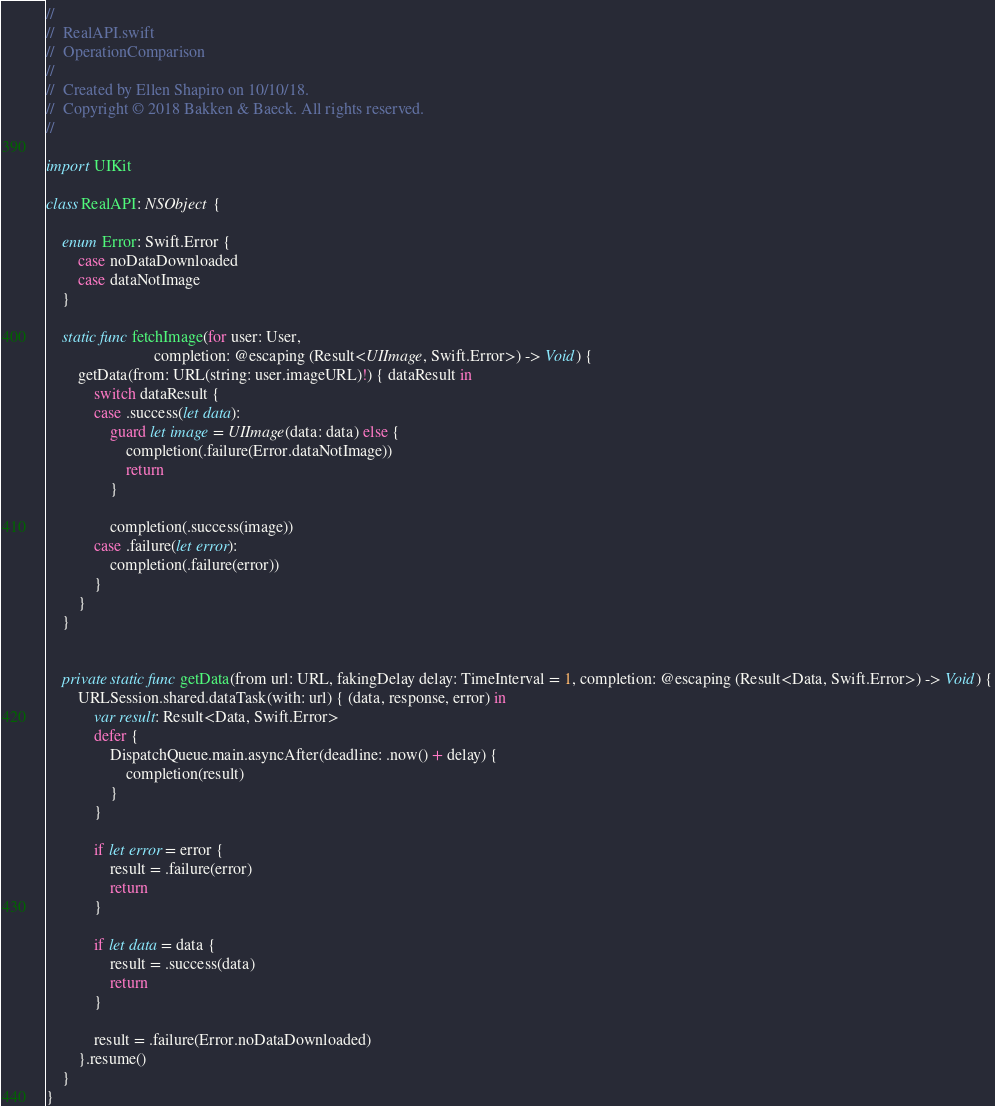Convert code to text. <code><loc_0><loc_0><loc_500><loc_500><_Swift_>//
//  RealAPI.swift
//  OperationComparison
//
//  Created by Ellen Shapiro on 10/10/18.
//  Copyright © 2018 Bakken & Baeck. All rights reserved.
//

import UIKit

class RealAPI: NSObject {
    
    enum Error: Swift.Error {
        case noDataDownloaded
        case dataNotImage
    }
    
    static func fetchImage(for user: User,
                           completion: @escaping (Result<UIImage, Swift.Error>) -> Void) {
        getData(from: URL(string: user.imageURL)!) { dataResult in
            switch dataResult {
            case .success(let data):
                guard let image = UIImage(data: data) else {
                    completion(.failure(Error.dataNotImage))
                    return
                }
                
                completion(.success(image))
            case .failure(let error):
                completion(.failure(error))
            }
        }
    }
    
    
    private static func getData(from url: URL, fakingDelay delay: TimeInterval = 1, completion: @escaping (Result<Data, Swift.Error>) -> Void) {
        URLSession.shared.dataTask(with: url) { (data, response, error) in
            var result: Result<Data, Swift.Error>
            defer {
                DispatchQueue.main.asyncAfter(deadline: .now() + delay) {
                    completion(result)
                }
            }
            
            if let error = error {
                result = .failure(error)
                return
            }
            
            if let data = data {
                result = .success(data)
                return
            }
            
            result = .failure(Error.noDataDownloaded)
        }.resume()
    }
}
</code> 